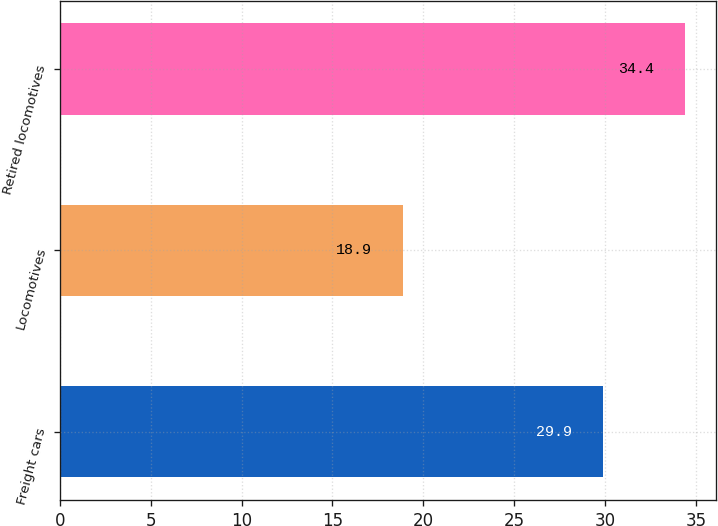Convert chart to OTSL. <chart><loc_0><loc_0><loc_500><loc_500><bar_chart><fcel>Freight cars<fcel>Locomotives<fcel>Retired locomotives<nl><fcel>29.9<fcel>18.9<fcel>34.4<nl></chart> 